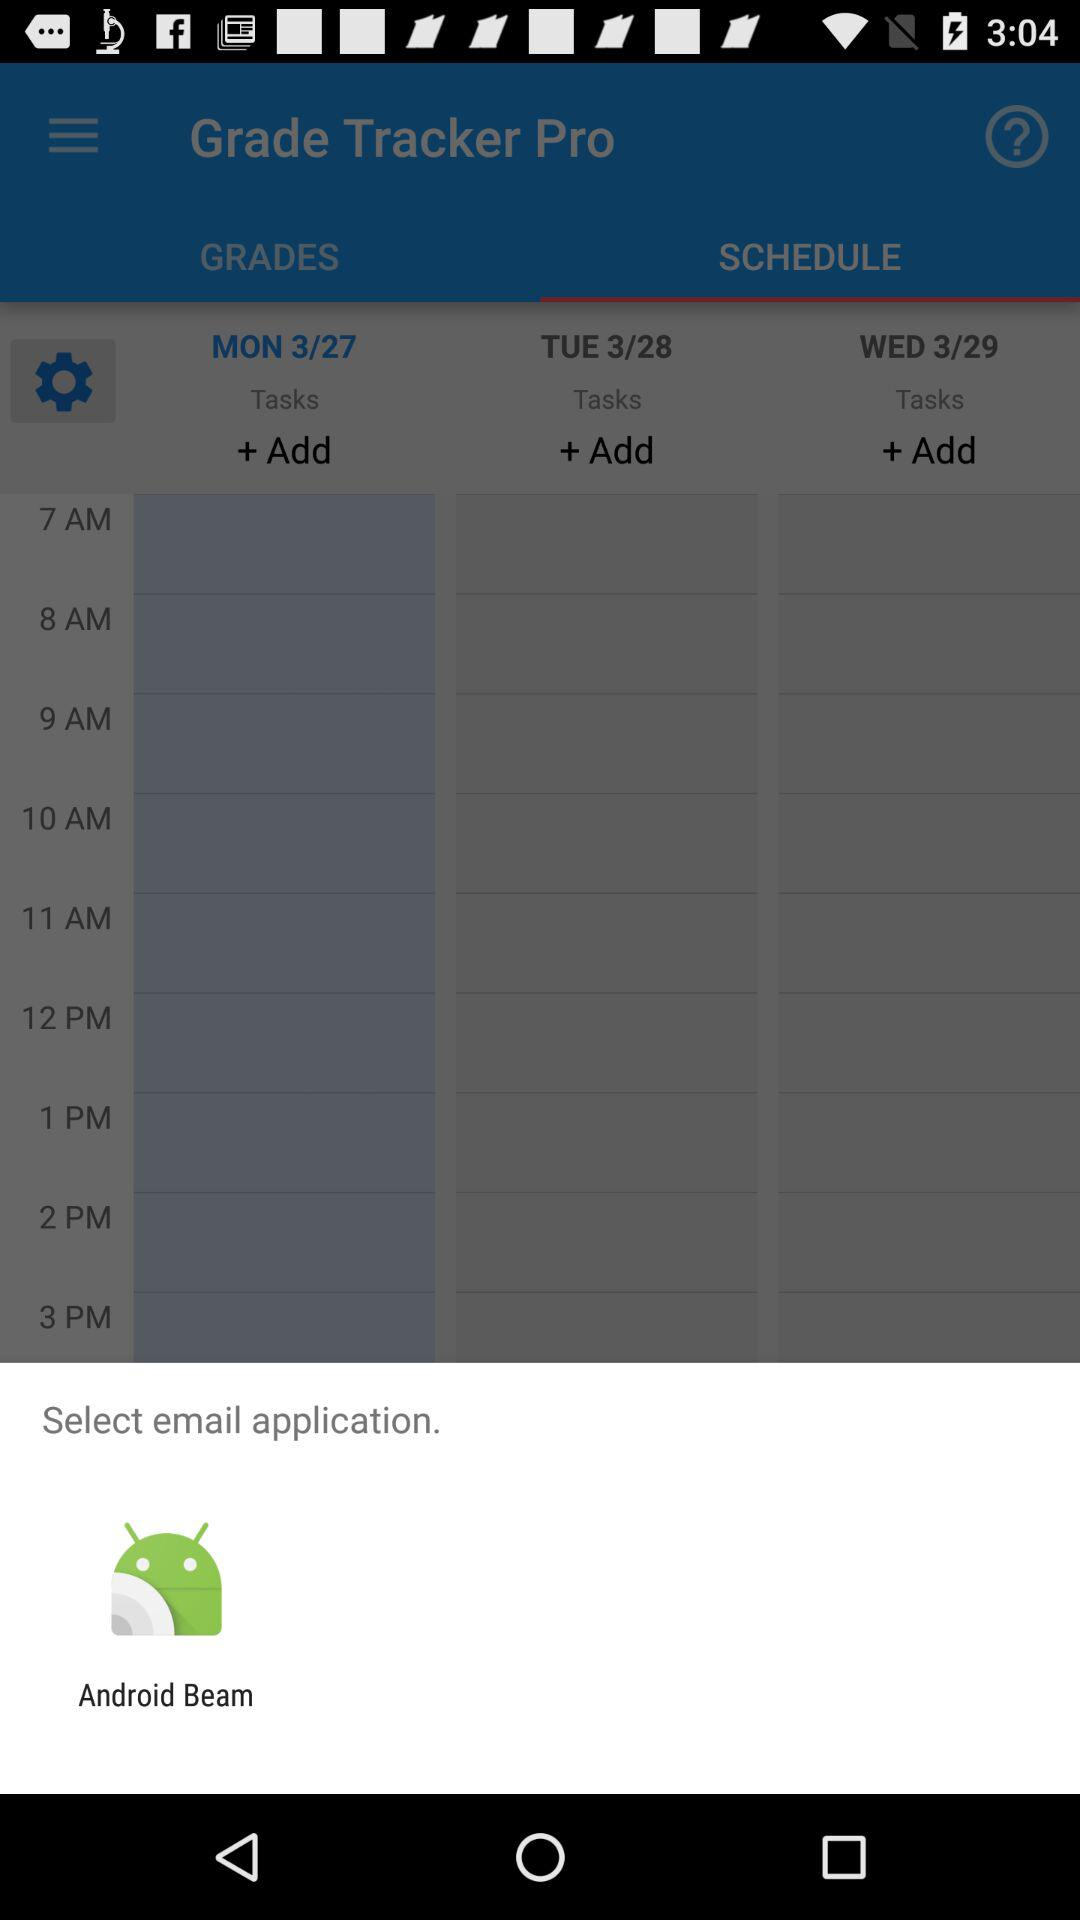How many days are displayed in the schedule?
Answer the question using a single word or phrase. 3 